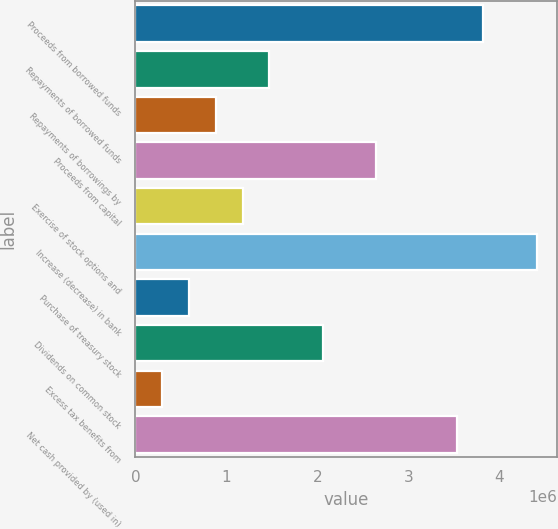Convert chart. <chart><loc_0><loc_0><loc_500><loc_500><bar_chart><fcel>Proceeds from borrowed funds<fcel>Repayments of borrowed funds<fcel>Repayments of borrowings by<fcel>Proceeds from capital<fcel>Exercise of stock options and<fcel>Increase (decrease) in bank<fcel>Purchase of treasury stock<fcel>Dividends on common stock<fcel>Excess tax benefits from<fcel>Net cash provided by (used in)<nl><fcel>3.82588e+06<fcel>1.47218e+06<fcel>883753<fcel>2.64903e+06<fcel>1.17797e+06<fcel>4.4143e+06<fcel>589541<fcel>2.0606e+06<fcel>295328<fcel>3.53166e+06<nl></chart> 